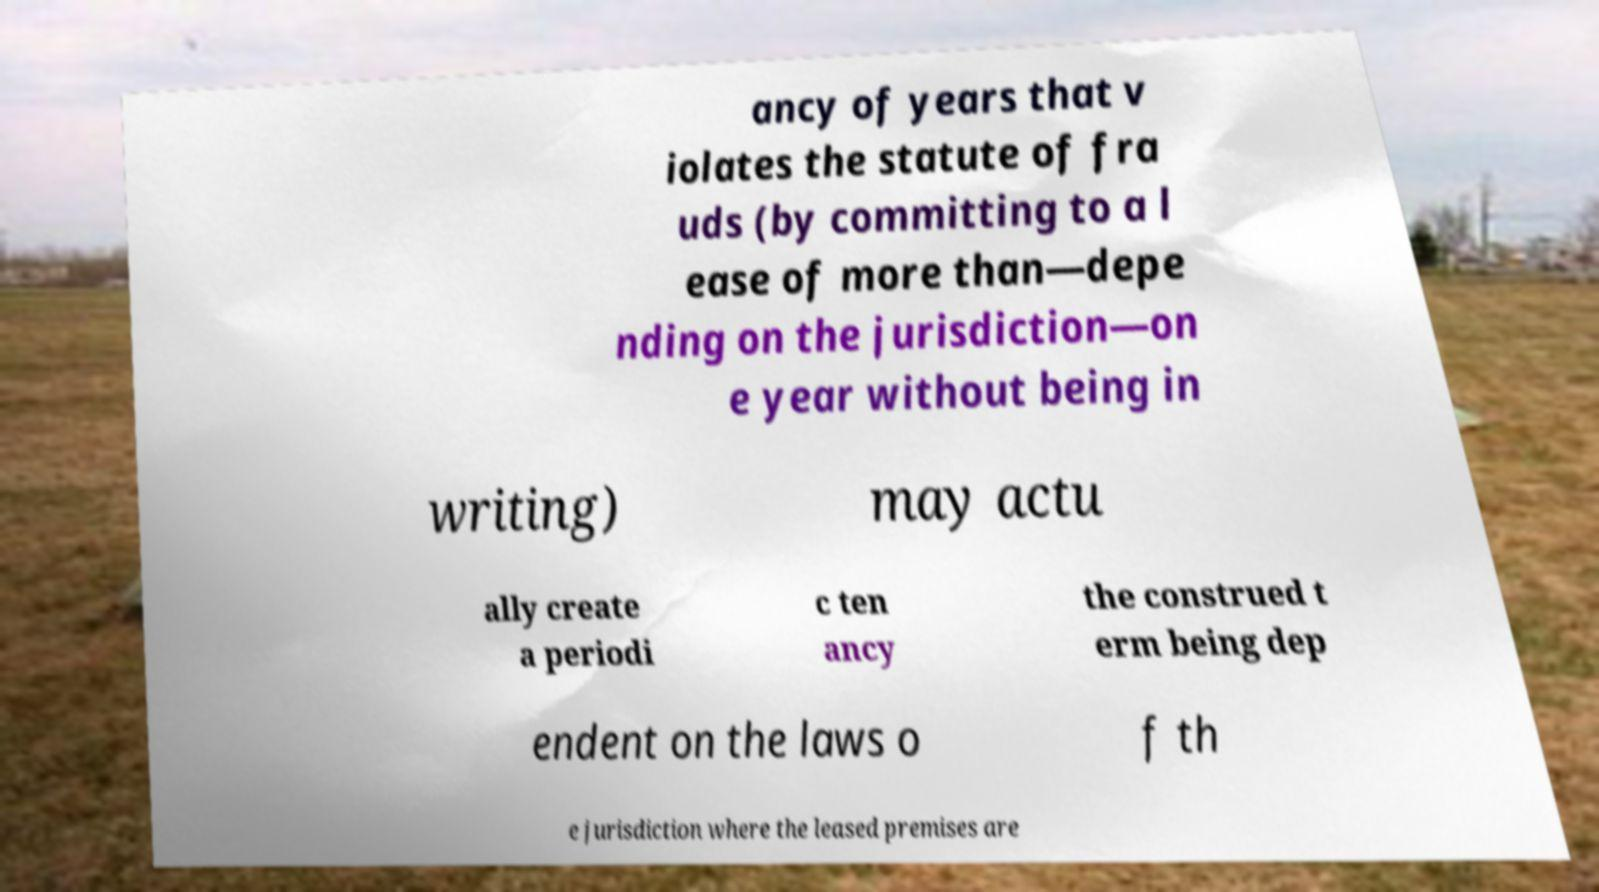I need the written content from this picture converted into text. Can you do that? ancy of years that v iolates the statute of fra uds (by committing to a l ease of more than—depe nding on the jurisdiction—on e year without being in writing) may actu ally create a periodi c ten ancy the construed t erm being dep endent on the laws o f th e jurisdiction where the leased premises are 